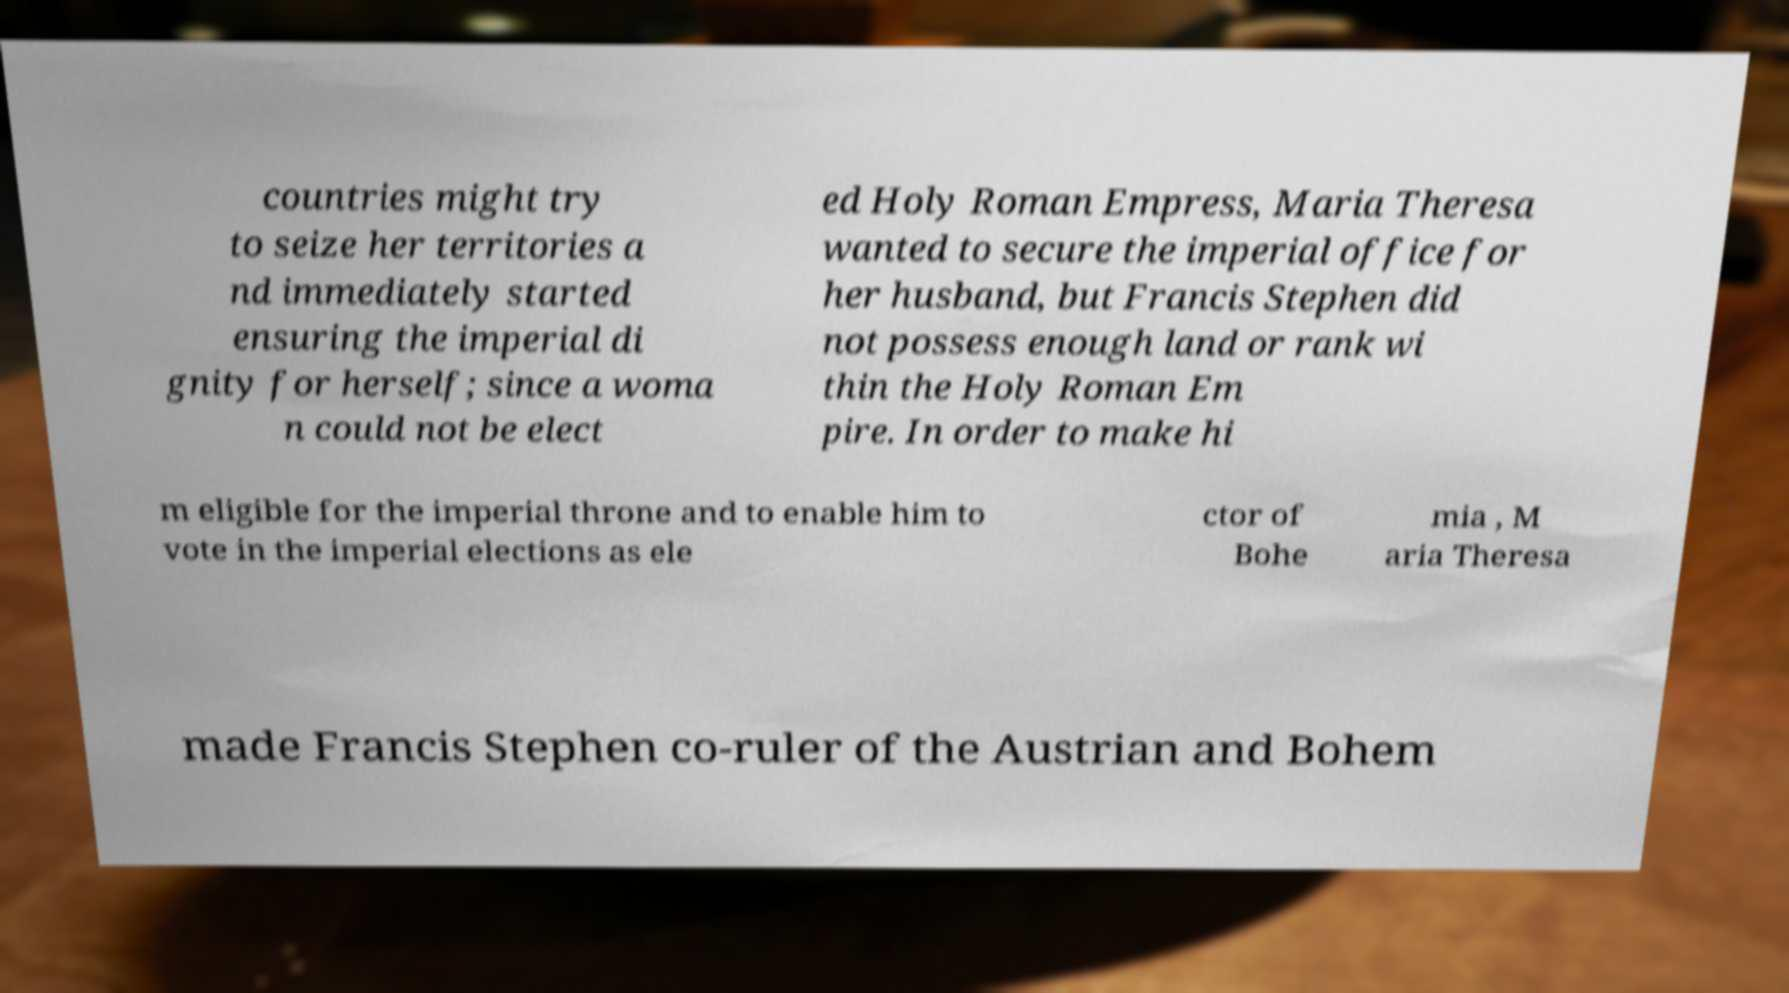Can you read and provide the text displayed in the image?This photo seems to have some interesting text. Can you extract and type it out for me? countries might try to seize her territories a nd immediately started ensuring the imperial di gnity for herself; since a woma n could not be elect ed Holy Roman Empress, Maria Theresa wanted to secure the imperial office for her husband, but Francis Stephen did not possess enough land or rank wi thin the Holy Roman Em pire. In order to make hi m eligible for the imperial throne and to enable him to vote in the imperial elections as ele ctor of Bohe mia , M aria Theresa made Francis Stephen co-ruler of the Austrian and Bohem 